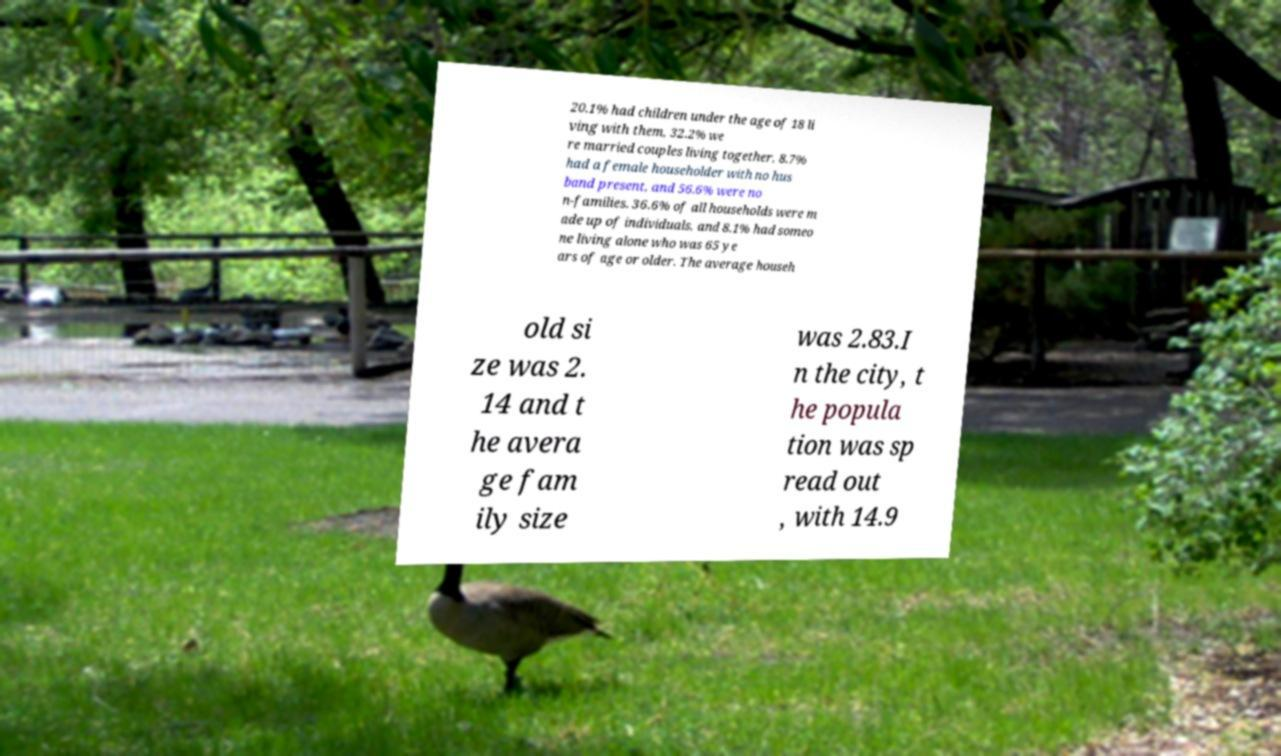Can you read and provide the text displayed in the image?This photo seems to have some interesting text. Can you extract and type it out for me? 20.1% had children under the age of 18 li ving with them, 32.2% we re married couples living together, 8.7% had a female householder with no hus band present, and 56.6% were no n-families. 36.6% of all households were m ade up of individuals, and 8.1% had someo ne living alone who was 65 ye ars of age or older. The average househ old si ze was 2. 14 and t he avera ge fam ily size was 2.83.I n the city, t he popula tion was sp read out , with 14.9 